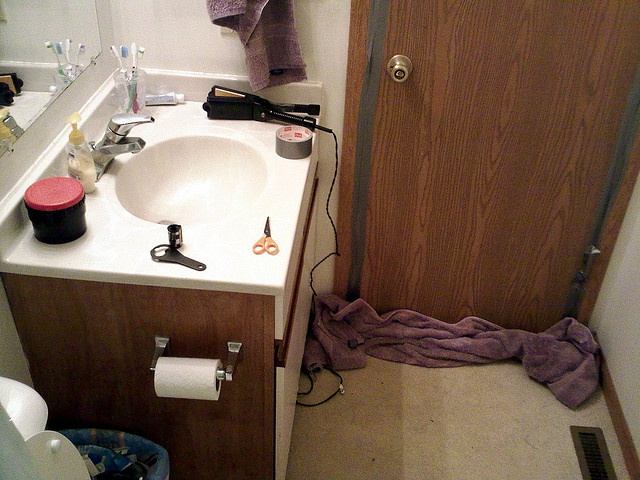Describe the objects in this image and their specific colors. I can see sink in gray, white, black, tan, and darkgray tones, toilet in gray, lightgray, and darkgray tones, bottle in gray and tan tones, scissors in gray, tan, and ivory tones, and toothbrush in gray, darkgray, lightgray, and tan tones in this image. 